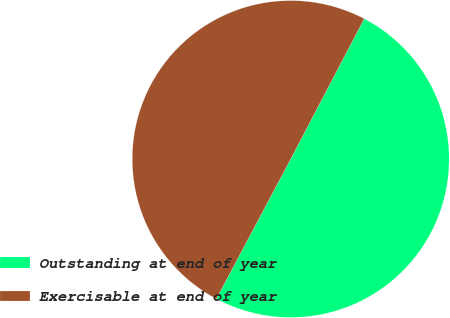Convert chart. <chart><loc_0><loc_0><loc_500><loc_500><pie_chart><fcel>Outstanding at end of year<fcel>Exercisable at end of year<nl><fcel>50.09%<fcel>49.91%<nl></chart> 